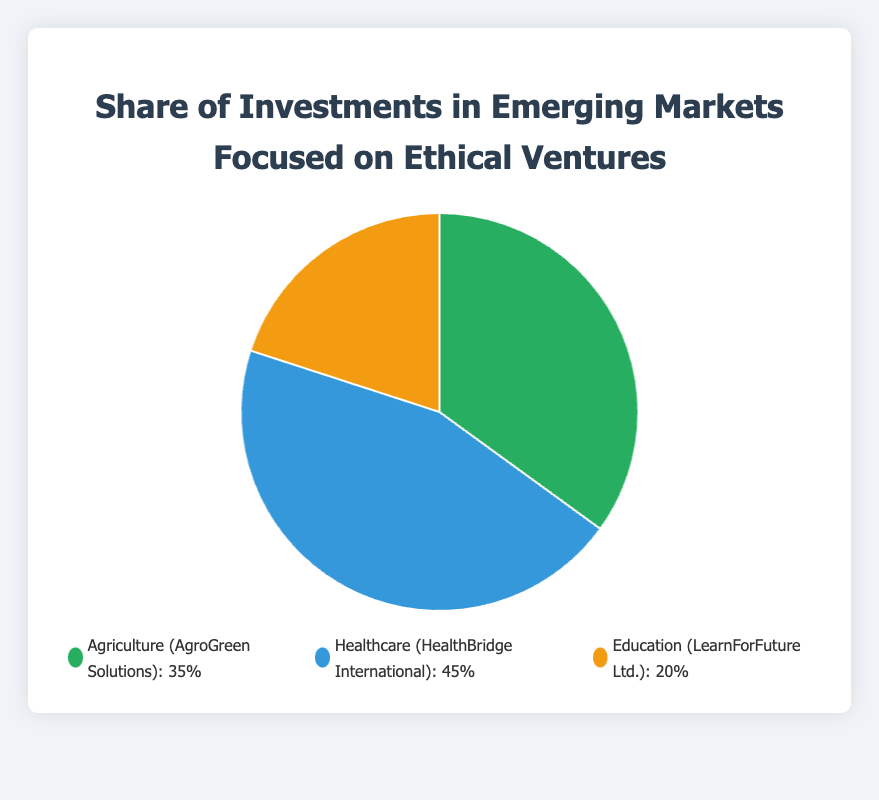What is the sector with the highest share of investments? The figure shows three sectors: Agriculture, Healthcare, and Education. Healthcare has the largest portion of the pie chart, which is 45%.
Answer: Healthcare What is the total share of investments for Agriculture and Education combined? To find the combined share, add the percentage for Agriculture (35%) to the percentage for Education (20%). 35% + 20% = 55%.
Answer: 55% Which sector has a lesser share of investments, Agriculture or Education? The figure shows that Agriculture has 35% and Education has 20%. Since 20% is less than 35%, Education has a lesser share of investments.
Answer: Education What percentage of investments is allocated to sectors other than Healthcare? The total percentage is 100%. Subtract the Healthcare share (45%) from 100%: 100% - 45% = 55%.
Answer: 55% What is the difference in the share of investments between Healthcare and Agriculture? Subtract the share of Agriculture (35%) from the share of Healthcare (45%): 45% - 35% = 10%.
Answer: 10% According to the pie chart, which sector has a yellow color representation? The legend on the chart shows sectors with their respective colors. Education is represented in yellow.
Answer: Education If an additional 5% were to be allocated to Education, what would its new share of investments be? Education's current share is 20%. Adding 5% to it gives 20% + 5% = 25%.
Answer: 25% What is the average share of investments across all three sectors? The shares of investments are 35%, 45%, and 20%. Calculate the average by summing them up and dividing by 3: (35% + 45% + 20%) / 3 = 100% / 3 ≈ 33.33%.
Answer: 33.33% Which sectors combined hold exactly 65% of the investments? Adding the shares of Agriculture (35%) and Healthcare (45%) gives 35% + 45% = 80%, which is more than 65%. Combining Agriculture (35%) and Education (20%) gives 35% + 20% = 55%, which is less than 65%. Therefore, only Healthcare (45%) and Education (20%) combine to exactly 65%.
Answer: Healthcare and Education 